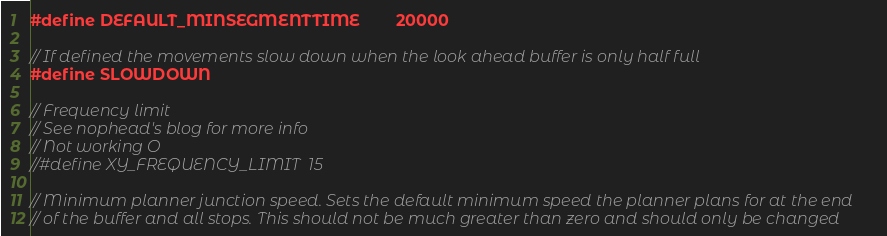<code> <loc_0><loc_0><loc_500><loc_500><_C_>#define DEFAULT_MINSEGMENTTIME        20000

// If defined the movements slow down when the look ahead buffer is only half full
#define SLOWDOWN

// Frequency limit
// See nophead's blog for more info
// Not working O
//#define XY_FREQUENCY_LIMIT  15

// Minimum planner junction speed. Sets the default minimum speed the planner plans for at the end
// of the buffer and all stops. This should not be much greater than zero and should only be changed</code> 